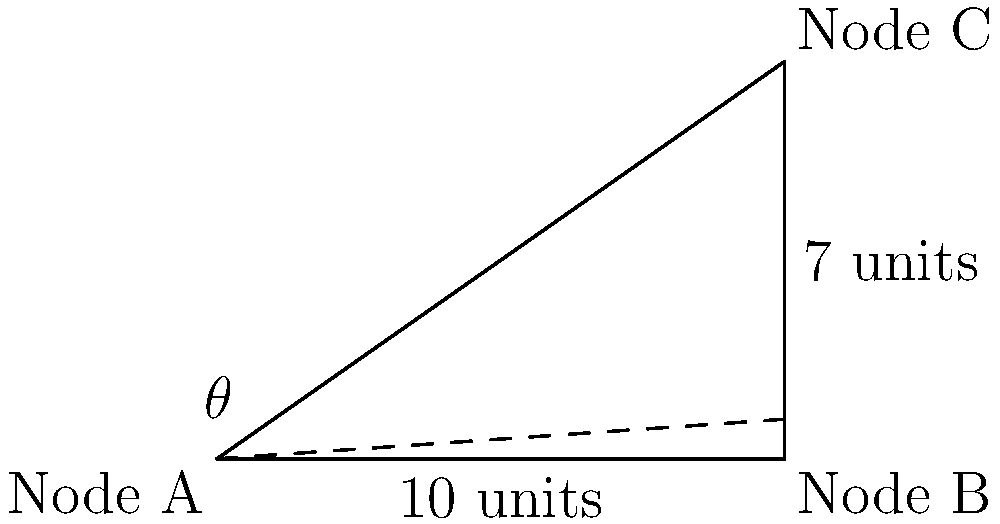In a Kubernetes cluster diagram, Node A and Node B are positioned 10 units apart on the same horizontal plane. Node C is directly above Node B at a height of 7 units. What is the angle of elevation ($\theta$) from Node A to Node C? To calculate the angle of elevation ($\theta$) from Node A to Node C, we can use the trigonometric function arctangent (atan or tan^(-1)).

Step 1: Identify the right triangle formed by Node A, Node B, and Node C.
- The adjacent side (horizontal distance) is 10 units.
- The opposite side (vertical distance) is 7 units.

Step 2: Use the arctangent function to calculate the angle:

$$\theta = \tan^{-1}(\frac{\text{opposite}}{\text{adjacent}})$$

$$\theta = \tan^{-1}(\frac{7}{10})$$

Step 3: Calculate the result:

$$\theta = \tan^{-1}(0.7)$$

$$\theta \approx 34.99^{\circ}$$

Step 4: Round to two decimal places:

$$\theta \approx 35.00^{\circ}$$

Therefore, the angle of elevation from Node A to Node C is approximately 35.00 degrees.
Answer: $35.00^{\circ}$ 